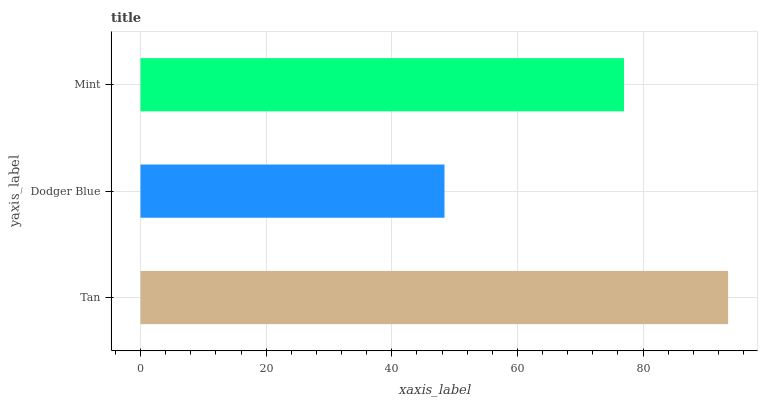Is Dodger Blue the minimum?
Answer yes or no. Yes. Is Tan the maximum?
Answer yes or no. Yes. Is Mint the minimum?
Answer yes or no. No. Is Mint the maximum?
Answer yes or no. No. Is Mint greater than Dodger Blue?
Answer yes or no. Yes. Is Dodger Blue less than Mint?
Answer yes or no. Yes. Is Dodger Blue greater than Mint?
Answer yes or no. No. Is Mint less than Dodger Blue?
Answer yes or no. No. Is Mint the high median?
Answer yes or no. Yes. Is Mint the low median?
Answer yes or no. Yes. Is Tan the high median?
Answer yes or no. No. Is Tan the low median?
Answer yes or no. No. 